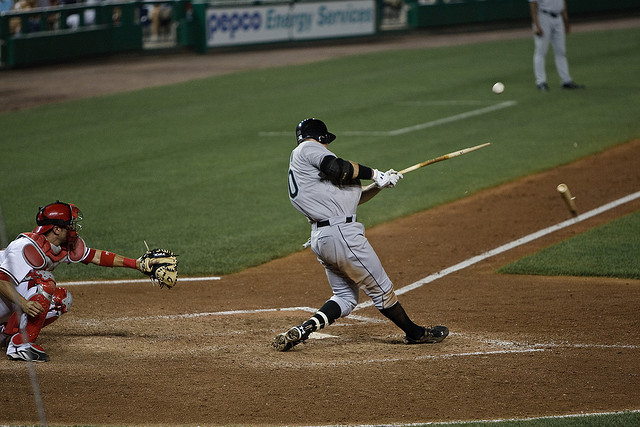Please transcribe the text information in this image. Services Energy pepco 